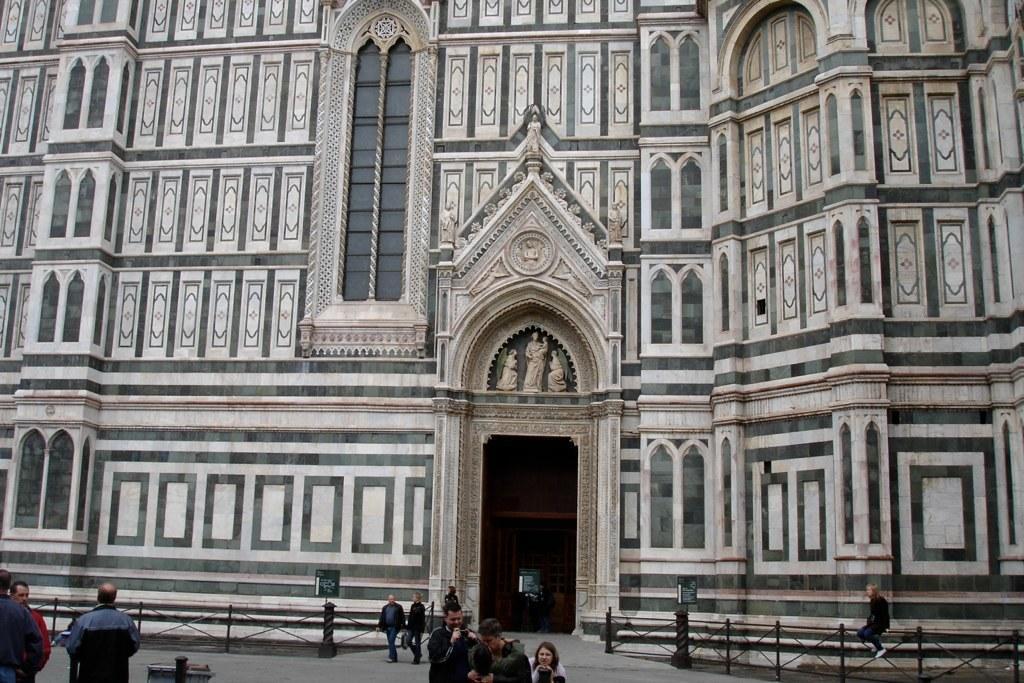What type of structure is visible in the image? There is a building in the image. What is located near the building? There is a fence in the image. Can you describe the people in the image? There are persons on the ground in the image. What type of pickle is being used to rake the beds in the image? There is no pickle or rake present in the image, nor are there any beds. 